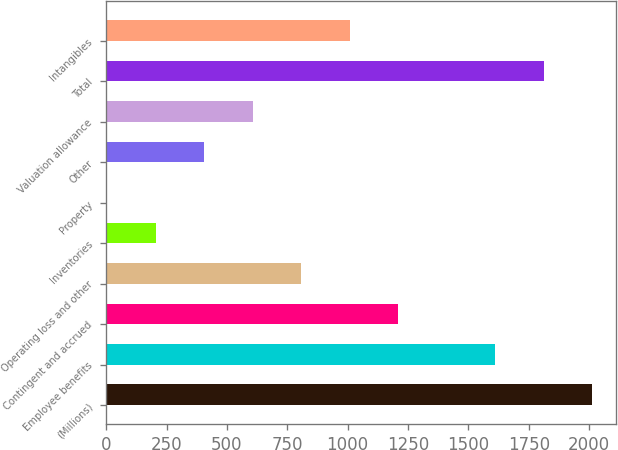Convert chart. <chart><loc_0><loc_0><loc_500><loc_500><bar_chart><fcel>(Millions)<fcel>Employee benefits<fcel>Contingent and accrued<fcel>Operating loss and other<fcel>Inventories<fcel>Property<fcel>Other<fcel>Valuation allowance<fcel>Total<fcel>Intangibles<nl><fcel>2012<fcel>1610.6<fcel>1209.2<fcel>807.8<fcel>205.7<fcel>5<fcel>406.4<fcel>607.1<fcel>1811.3<fcel>1008.5<nl></chart> 